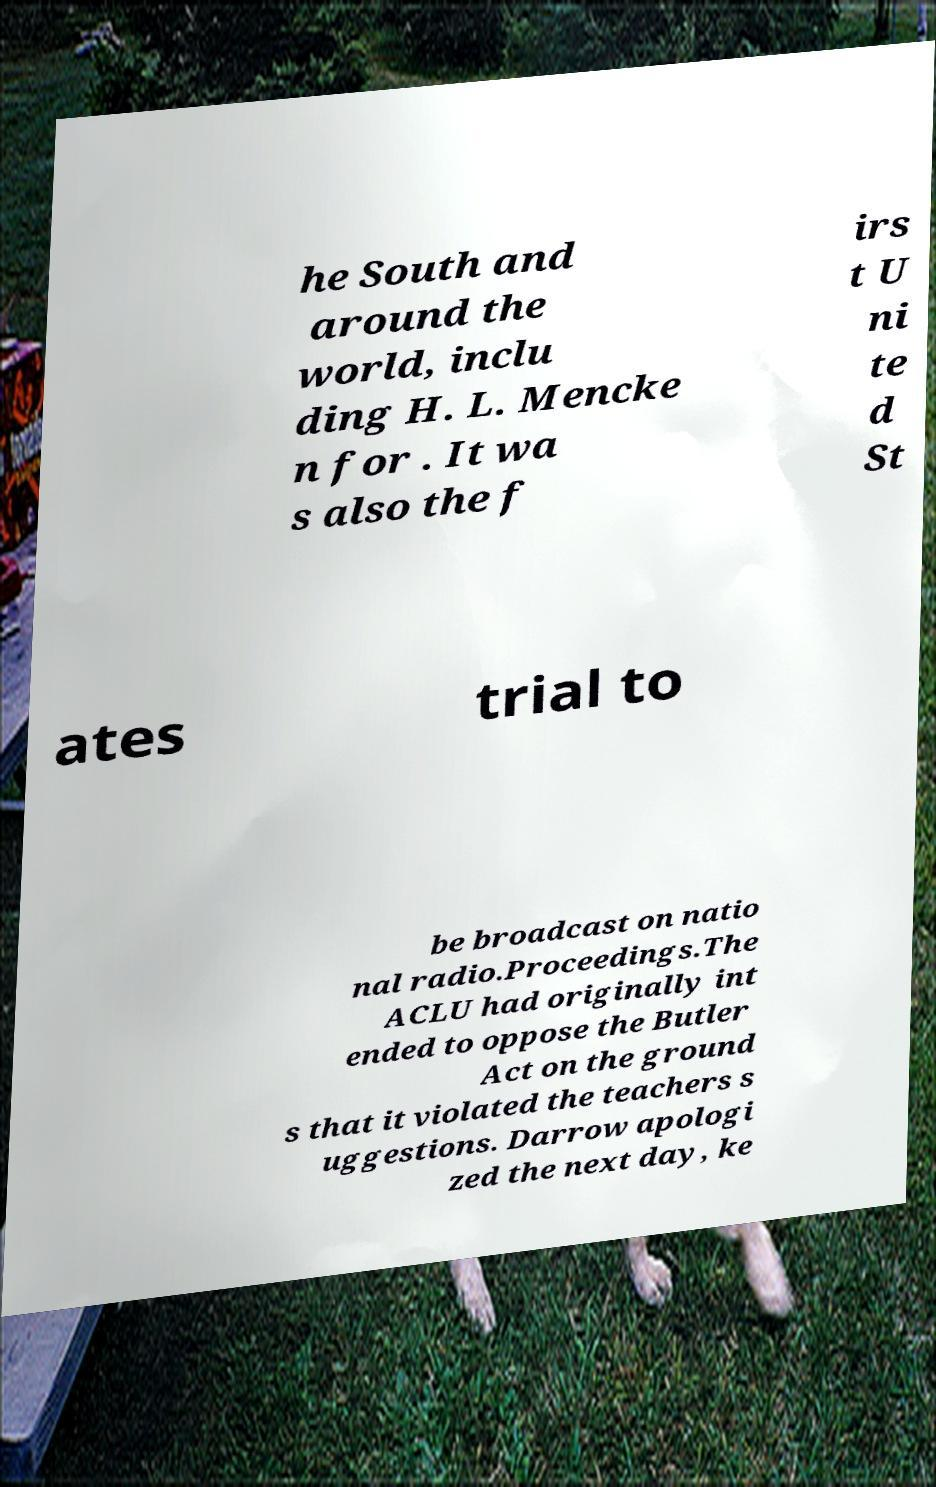For documentation purposes, I need the text within this image transcribed. Could you provide that? he South and around the world, inclu ding H. L. Mencke n for . It wa s also the f irs t U ni te d St ates trial to be broadcast on natio nal radio.Proceedings.The ACLU had originally int ended to oppose the Butler Act on the ground s that it violated the teachers s uggestions. Darrow apologi zed the next day, ke 